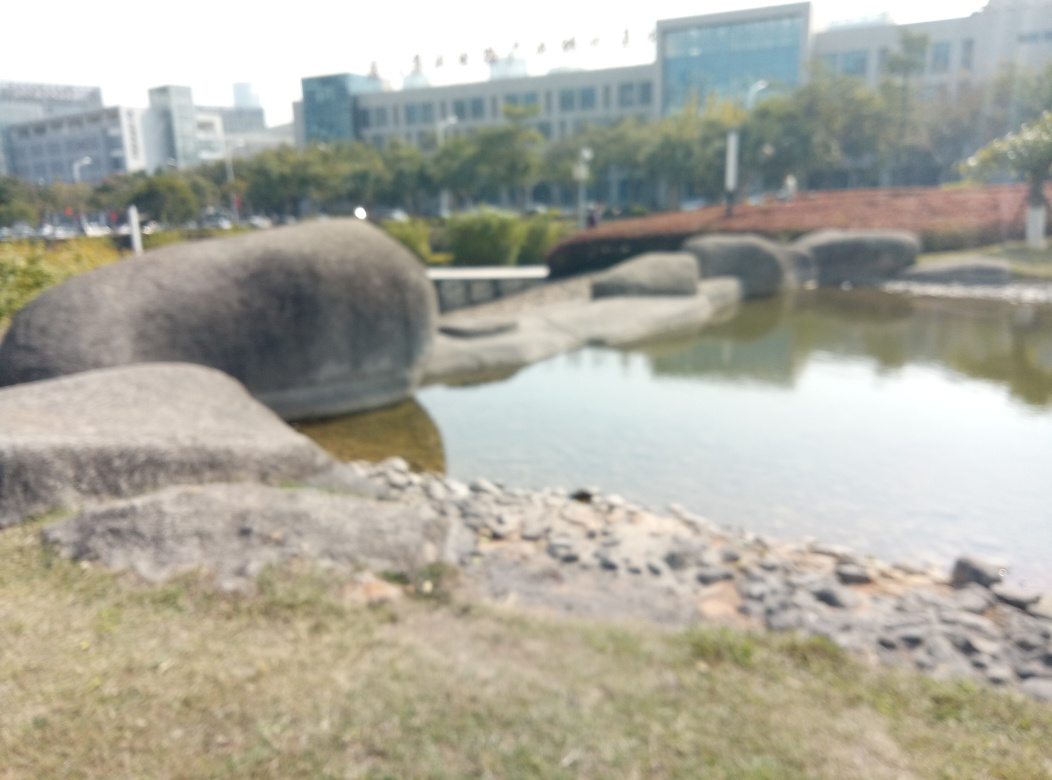What happened to the texture details of the image?
A. Enhanced
B. Lost
C. Sharpened
D. Highlighted
Answer with the option's letter from the given choices directly.
 B. 